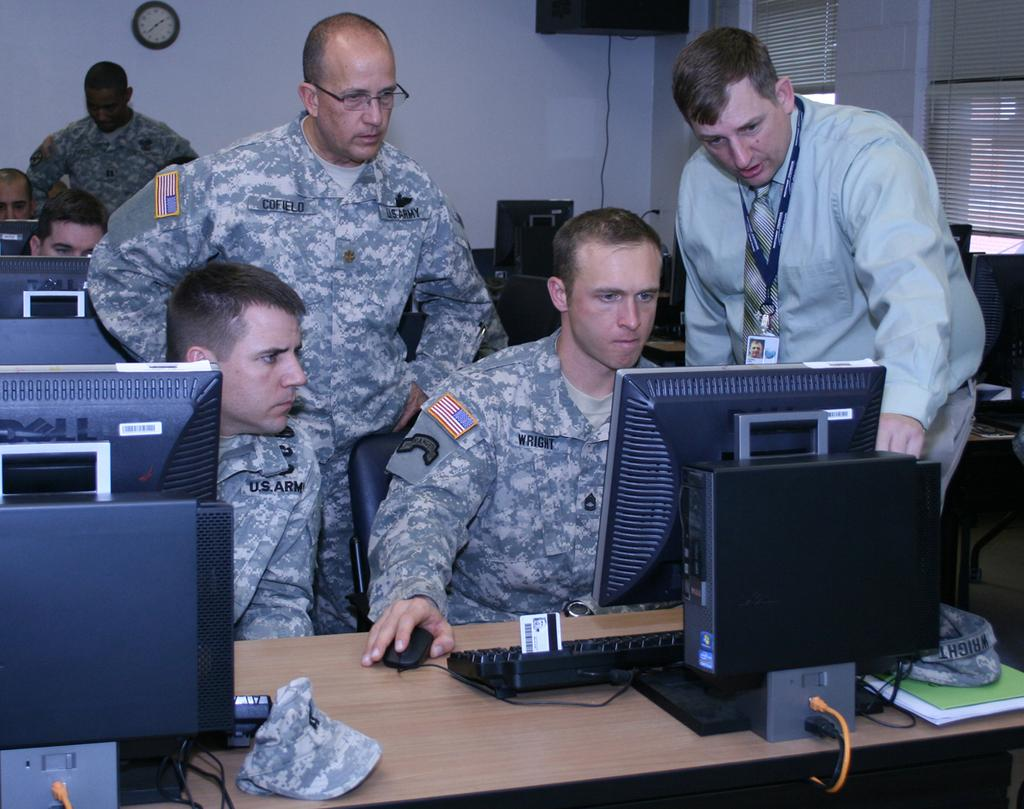<image>
Offer a succinct explanation of the picture presented. Military people looking at a computer screen, one's name tag reads Cofield 